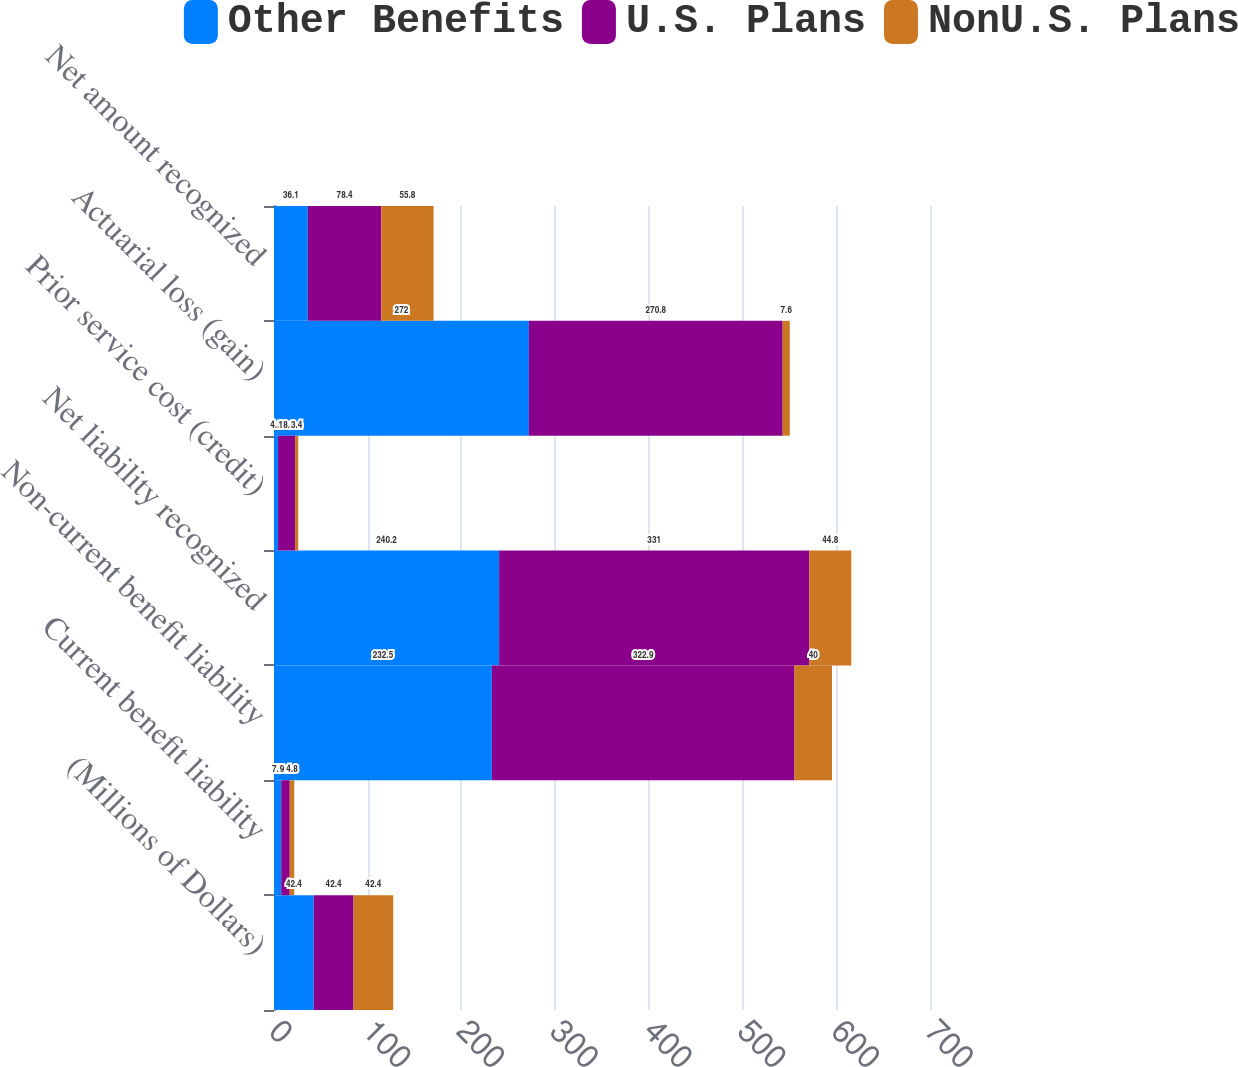Convert chart. <chart><loc_0><loc_0><loc_500><loc_500><stacked_bar_chart><ecel><fcel>(Millions of Dollars)<fcel>Current benefit liability<fcel>Non-current benefit liability<fcel>Net liability recognized<fcel>Prior service cost (credit)<fcel>Actuarial loss (gain)<fcel>Net amount recognized<nl><fcel>Other Benefits<fcel>42.4<fcel>7.7<fcel>232.5<fcel>240.2<fcel>4.3<fcel>272<fcel>36.1<nl><fcel>U.S. Plans<fcel>42.4<fcel>9.1<fcel>322.9<fcel>331<fcel>18.2<fcel>270.8<fcel>78.4<nl><fcel>NonU.S. Plans<fcel>42.4<fcel>4.8<fcel>40<fcel>44.8<fcel>3.4<fcel>7.6<fcel>55.8<nl></chart> 